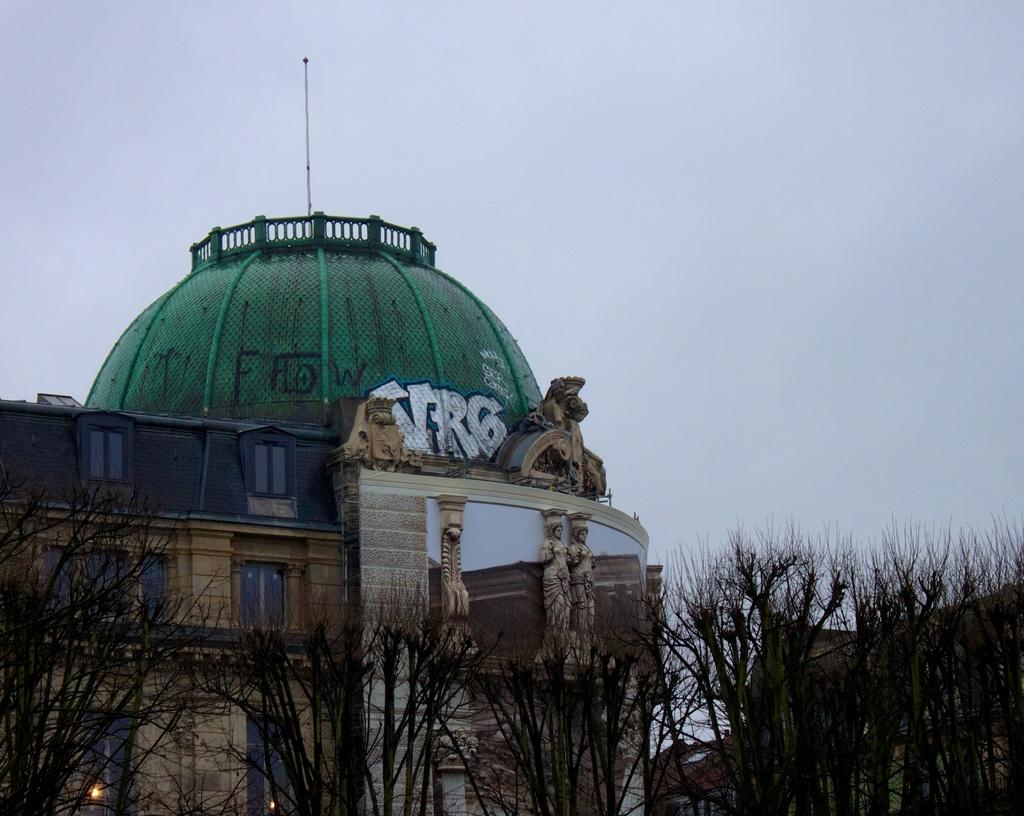What type of structures can be seen in the image? There are buildings in the image. What natural elements are present in the image? There are trees in the image. What can be seen illuminating the scene in the image? There are lights in the image. How many cats can be seen playing with a carriage in the image? There are no cats or carriages present in the image. What is the purpose of the trees in the image? The purpose of the trees in the image cannot be determined from the image alone, as trees serve various purposes in real life. 